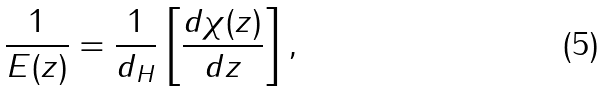<formula> <loc_0><loc_0><loc_500><loc_500>\frac { 1 } { E ( z ) } = \frac { 1 } { d _ { H } } \left [ \frac { d \chi ( z ) } { d z } \right ] ,</formula> 